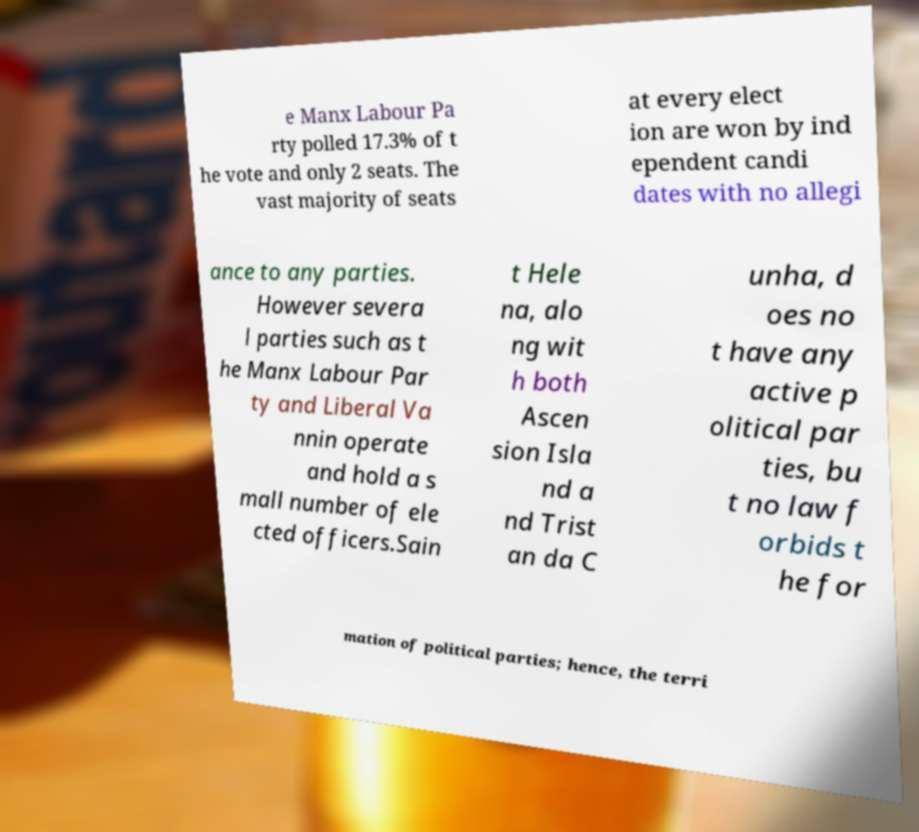Please identify and transcribe the text found in this image. e Manx Labour Pa rty polled 17.3% of t he vote and only 2 seats. The vast majority of seats at every elect ion are won by ind ependent candi dates with no allegi ance to any parties. However severa l parties such as t he Manx Labour Par ty and Liberal Va nnin operate and hold a s mall number of ele cted officers.Sain t Hele na, alo ng wit h both Ascen sion Isla nd a nd Trist an da C unha, d oes no t have any active p olitical par ties, bu t no law f orbids t he for mation of political parties; hence, the terri 